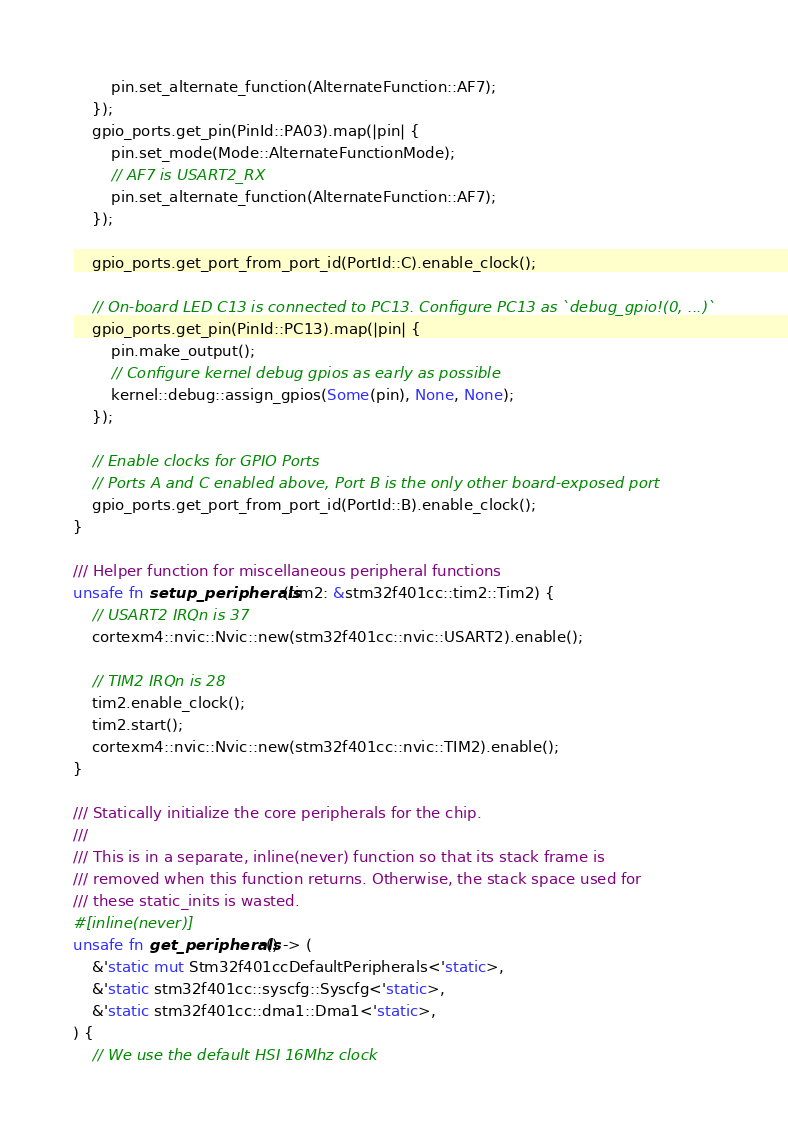Convert code to text. <code><loc_0><loc_0><loc_500><loc_500><_Rust_>        pin.set_alternate_function(AlternateFunction::AF7);
    });
    gpio_ports.get_pin(PinId::PA03).map(|pin| {
        pin.set_mode(Mode::AlternateFunctionMode);
        // AF7 is USART2_RX
        pin.set_alternate_function(AlternateFunction::AF7);
    });

    gpio_ports.get_port_from_port_id(PortId::C).enable_clock();

    // On-board LED C13 is connected to PC13. Configure PC13 as `debug_gpio!(0, ...)`
    gpio_ports.get_pin(PinId::PC13).map(|pin| {
        pin.make_output();
        // Configure kernel debug gpios as early as possible
        kernel::debug::assign_gpios(Some(pin), None, None);
    });

    // Enable clocks for GPIO Ports
    // Ports A and C enabled above, Port B is the only other board-exposed port
    gpio_ports.get_port_from_port_id(PortId::B).enable_clock();
}

/// Helper function for miscellaneous peripheral functions
unsafe fn setup_peripherals(tim2: &stm32f401cc::tim2::Tim2) {
    // USART2 IRQn is 37
    cortexm4::nvic::Nvic::new(stm32f401cc::nvic::USART2).enable();

    // TIM2 IRQn is 28
    tim2.enable_clock();
    tim2.start();
    cortexm4::nvic::Nvic::new(stm32f401cc::nvic::TIM2).enable();
}

/// Statically initialize the core peripherals for the chip.
///
/// This is in a separate, inline(never) function so that its stack frame is
/// removed when this function returns. Otherwise, the stack space used for
/// these static_inits is wasted.
#[inline(never)]
unsafe fn get_peripherals() -> (
    &'static mut Stm32f401ccDefaultPeripherals<'static>,
    &'static stm32f401cc::syscfg::Syscfg<'static>,
    &'static stm32f401cc::dma1::Dma1<'static>,
) {
    // We use the default HSI 16Mhz clock</code> 